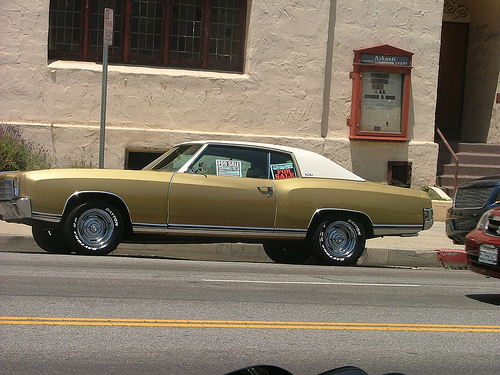<image>
Is there a sign on the car? Yes. Looking at the image, I can see the sign is positioned on top of the car, with the car providing support. Is there a car behind the building? No. The car is not behind the building. From this viewpoint, the car appears to be positioned elsewhere in the scene. 